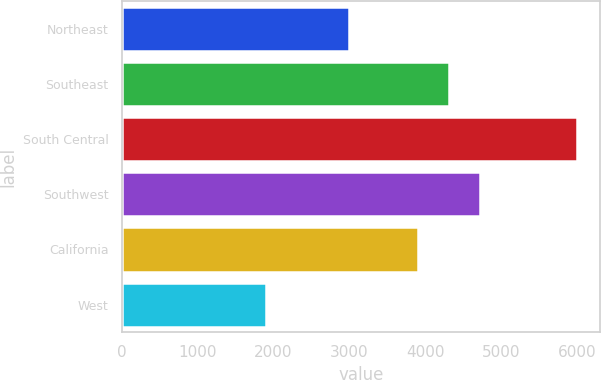Convert chart to OTSL. <chart><loc_0><loc_0><loc_500><loc_500><bar_chart><fcel>Northeast<fcel>Southeast<fcel>South Central<fcel>Southwest<fcel>California<fcel>West<nl><fcel>3000<fcel>4310<fcel>6000<fcel>4720<fcel>3900<fcel>1900<nl></chart> 